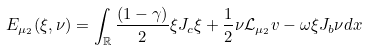Convert formula to latex. <formula><loc_0><loc_0><loc_500><loc_500>E _ { \mu _ { 2 } } ( \xi , \nu ) = \int _ { \mathbb { R } } \frac { ( 1 - \gamma ) } { 2 } \xi J _ { c } \xi + \frac { 1 } { 2 } \nu \mathcal { L } _ { \mu _ { 2 } } v - \omega \xi J _ { b } \nu d x</formula> 